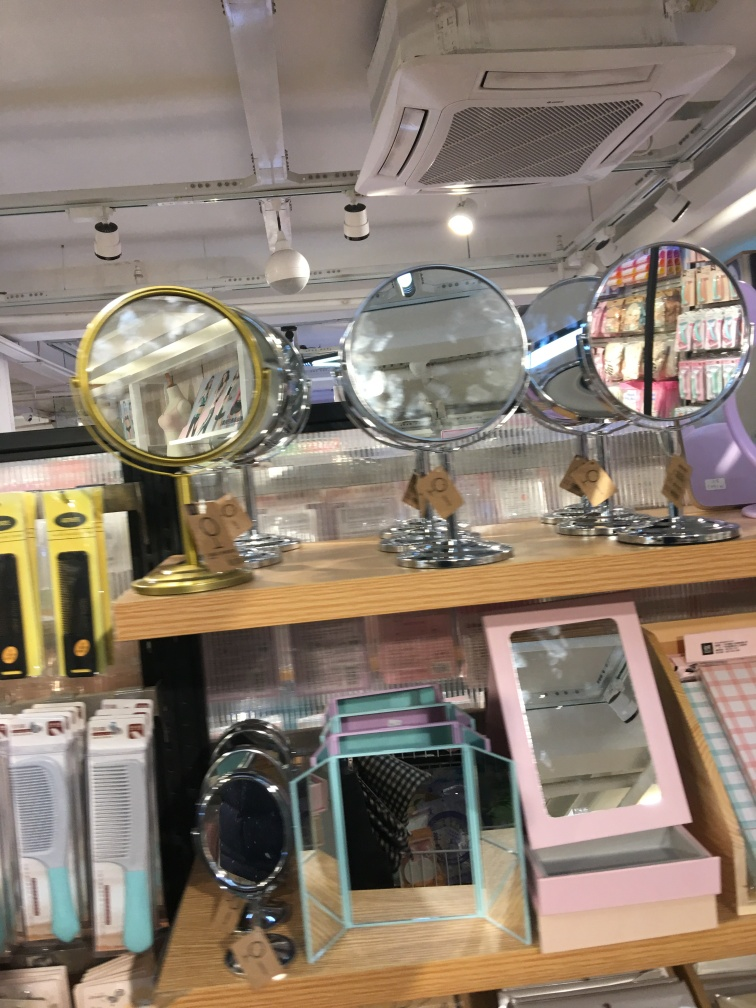What might be the purpose of using multiple mirrors in this way? Displaying multiple mirrors together serves a practical purpose as well as a visual one. Shoppers can compare different sizes, shapes, and styles side by side, making it easier to choose the one that best suits their needs. Visually, mirrors can make the space look bigger and more open, creating an appealing aesthetic for the store. They also reflect light, which can brighten the area and make it more inviting. 